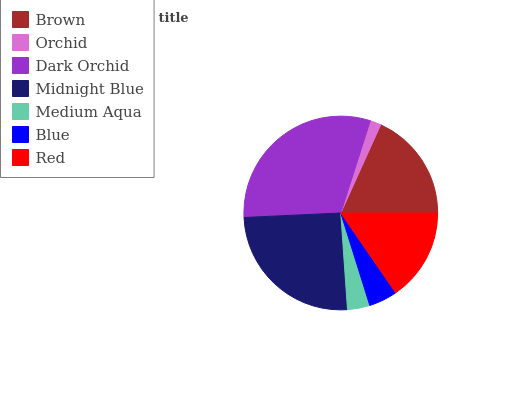Is Orchid the minimum?
Answer yes or no. Yes. Is Dark Orchid the maximum?
Answer yes or no. Yes. Is Dark Orchid the minimum?
Answer yes or no. No. Is Orchid the maximum?
Answer yes or no. No. Is Dark Orchid greater than Orchid?
Answer yes or no. Yes. Is Orchid less than Dark Orchid?
Answer yes or no. Yes. Is Orchid greater than Dark Orchid?
Answer yes or no. No. Is Dark Orchid less than Orchid?
Answer yes or no. No. Is Red the high median?
Answer yes or no. Yes. Is Red the low median?
Answer yes or no. Yes. Is Midnight Blue the high median?
Answer yes or no. No. Is Midnight Blue the low median?
Answer yes or no. No. 